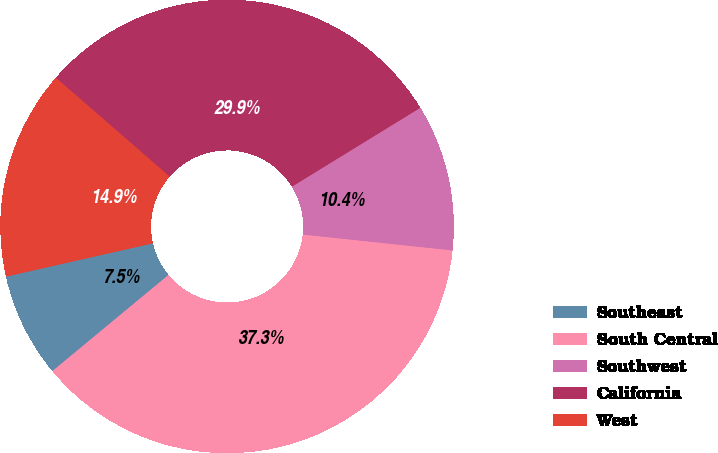<chart> <loc_0><loc_0><loc_500><loc_500><pie_chart><fcel>Southeast<fcel>South Central<fcel>Southwest<fcel>California<fcel>West<nl><fcel>7.46%<fcel>37.31%<fcel>10.45%<fcel>29.85%<fcel>14.93%<nl></chart> 